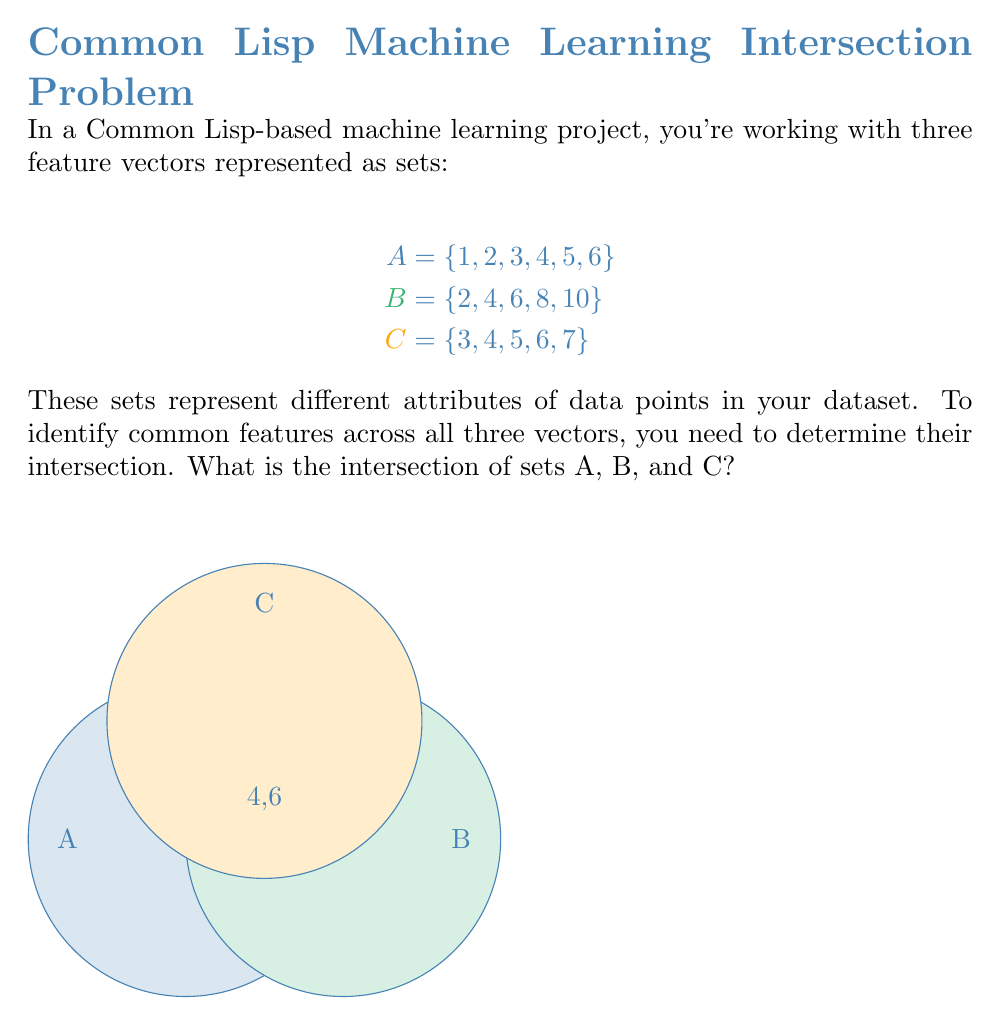Help me with this question. To find the intersection of sets A, B, and C, we need to identify the elements that are present in all three sets. Let's approach this step-by-step:

1) First, let's list out the elements of each set:
   A = {1, 2, 3, 4, 5, 6}
   B = {2, 4, 6, 8, 10}
   C = {3, 4, 5, 6, 7}

2) Now, let's identify the elements that are common to at least two sets:
   - Common to A and B: 2, 4, 6
   - Common to A and C: 3, 4, 5, 6
   - Common to B and C: 4, 6

3) From these common elements, we need to find which ones are present in all three sets. We can see that 4 and 6 are the only elements that appear in all lists from step 2.

4) Therefore, the intersection of A, B, and C is {4, 6}.

In set notation, this can be written as:

$$A \cap B \cap C = \{4, 6\}$$

In Common Lisp, you could represent this intersection using a list:
(list 4 6)

This result indicates that features 4 and 6 are present in all three feature vectors, which could be significant for your machine learning model.
Answer: $\{4, 6\}$ 